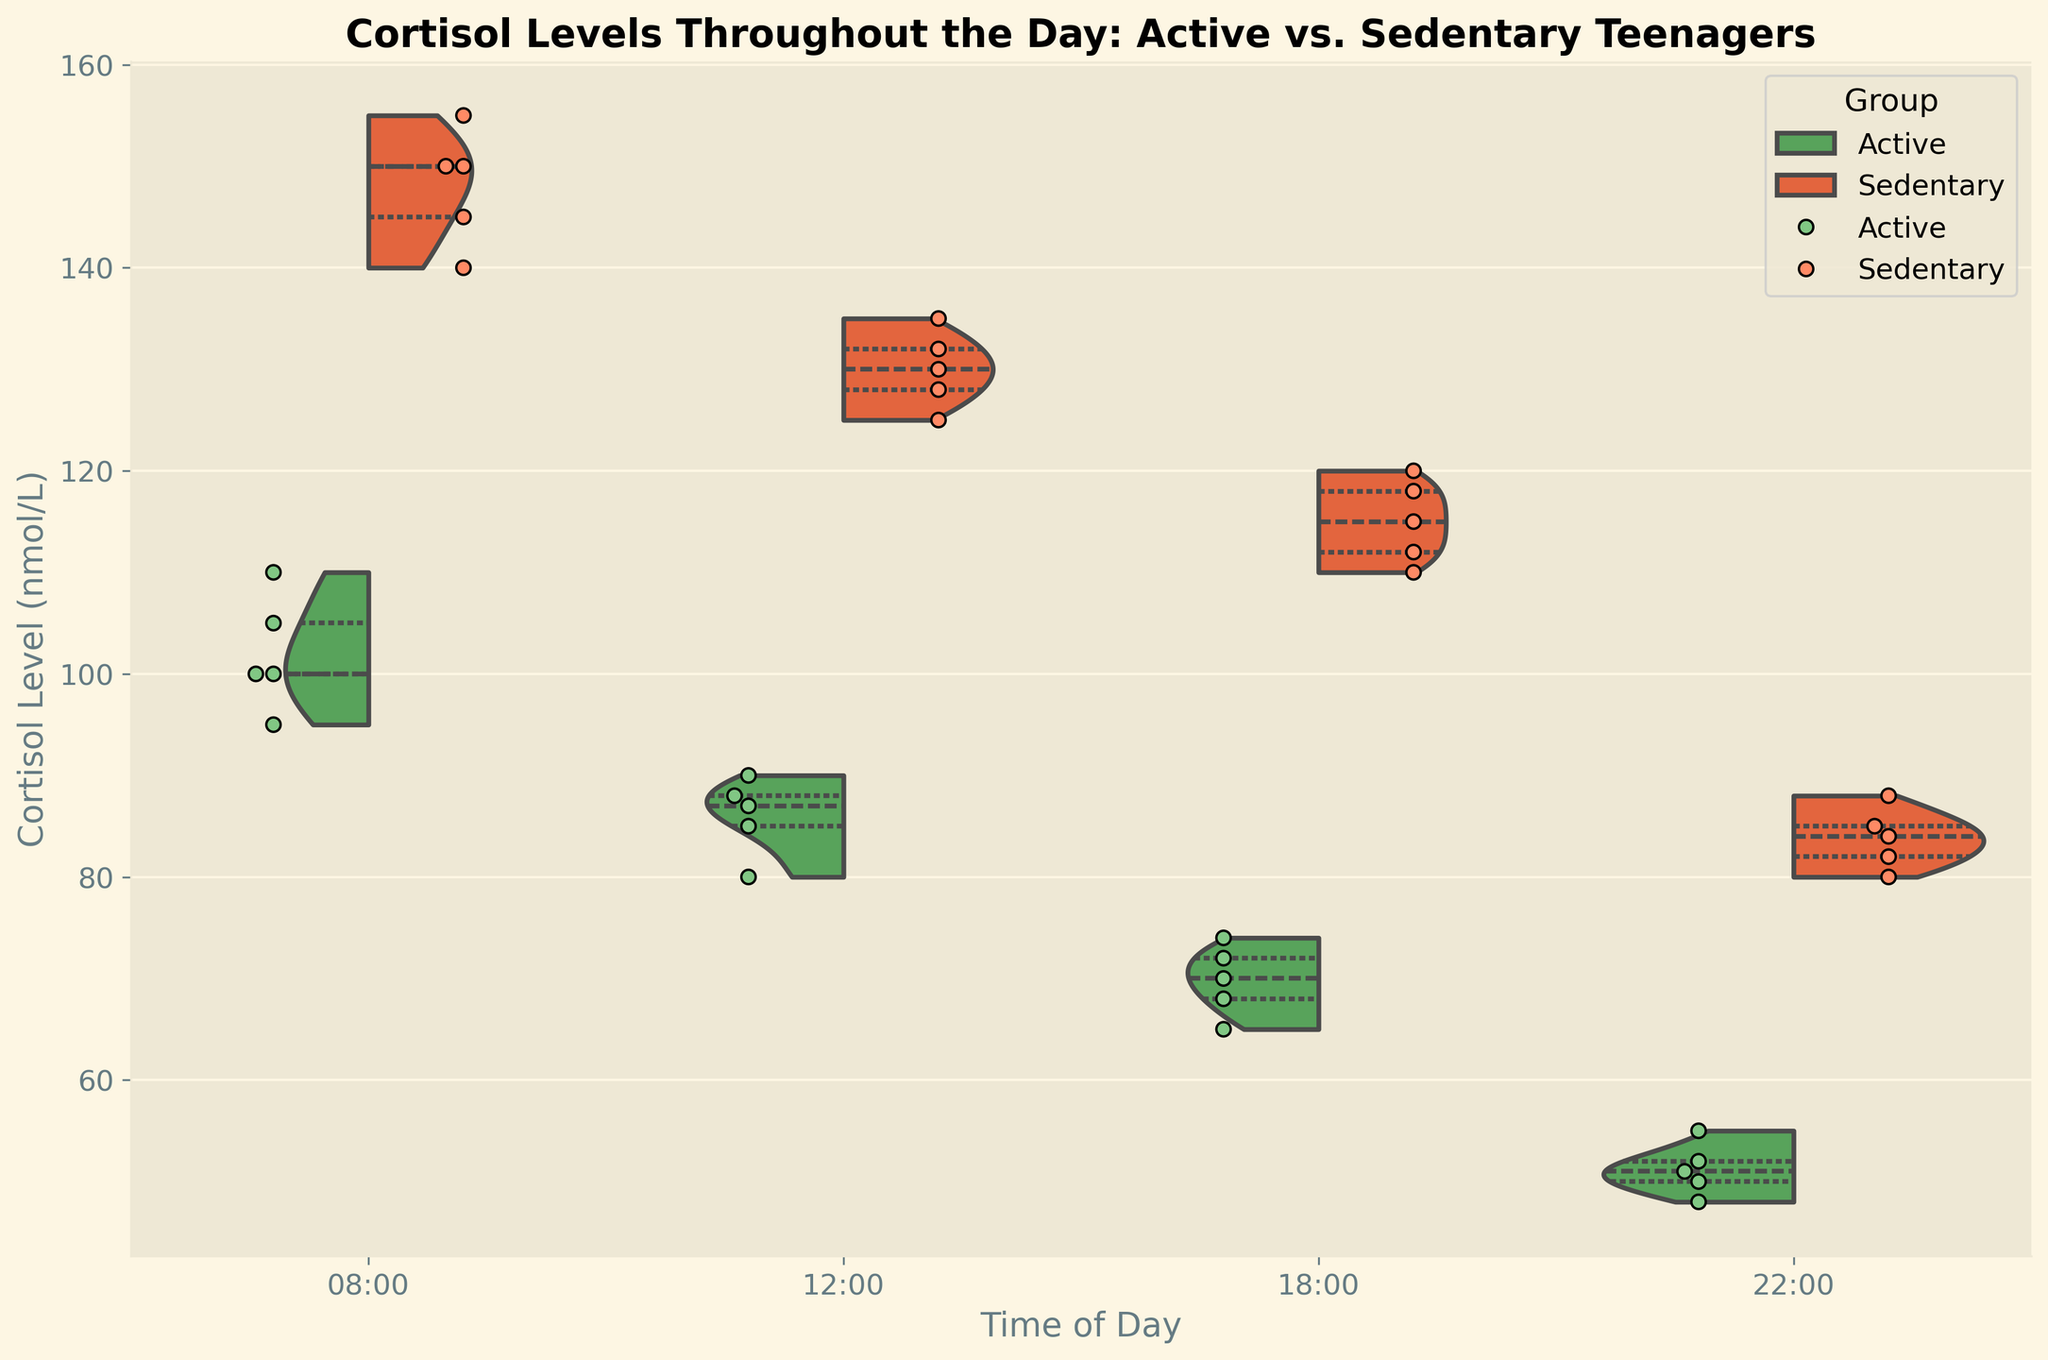What is the title of the figure? The title is usually found at the top of the figure. It provides a brief description of what the figure is about. In this case, the title is "Cortisol Levels Throughout the Day: Active vs. Sedentary Teenagers."
Answer: Cortisol Levels Throughout the Day: Active vs. Sedentary Teenagers At which time point do sedentary teenagers have the highest median cortisol level? By looking at the figure, you can identify the median cortisol level for each group at different timestamps. The highest median level for sedentary teenagers appears at 08:00.
Answer: 08:00 Comparing the two groups, at 12:00, which group has a higher variability in cortisol levels? In a violin plot, the width of the plot at various heights represents the variability in the data. For 12:00, you can see that the width of the violin plot for sedentary teenagers is greater compared to active teenagers, indicating higher variability.
Answer: Sedentary What is the general trend of cortisol levels throughout the day for active teenagers? Observing the median quartile lines in the violin plot for active teenagers across the timestamps, you can see that the cortisol levels show a decreasing trend from 08:00 to 22:00.
Answer: Decreasing At 18:00, what is the approximate range of cortisol levels for sedentary teenagers? The range can be identified by looking at the outer edges of the violin plot for sedentary teenagers at 18:00. The range appears to be approximately from 110 to 120 nmol/L.
Answer: 110 to 120 nmol/L What's the difference between the medians of active and sedentary groups at 22:00? The median can be identified by looking at the central line in the “quartile” representation within the violin plot. At 22:00, the median for active teenagers is slightly above 50 nmol/L, and for sedentary teenagers, it is approximately 84 nmol/L. The difference is 84 - 50 = 34 nmol/L.
Answer: 34 nmol/L How many samples are shown in the figure for each group at each time point? The jittered points (dots) overlaid on the violin plot represent the number of samples. There are 5 samples for each group (active and sedentary) at each timestamp (08:00, 12:00, 18:00, and 22:00).
Answer: 5 Which group generally has higher cortisol levels, and is this consistent across all time points? By examining the central tendency and spread of the violin plots for both groups at all time points, it is evident that the sedentary group generally has higher cortisol levels than the active group. This trend is consistent across all time points.
Answer: Sedentary, Yes At 08:00, what is the interquartile range (IQR) for the active group? The IQR is the range between the first quartile (25th percentile) and the third quartile (75th percentile) in the violin plot. For the active group at 08:00, the central 50% (from the density plot) appears to be between approximately 95 and 105 nmol/L. The IQR is 105 - 95 = 10 nmol/L.
Answer: 10 nmol/L 